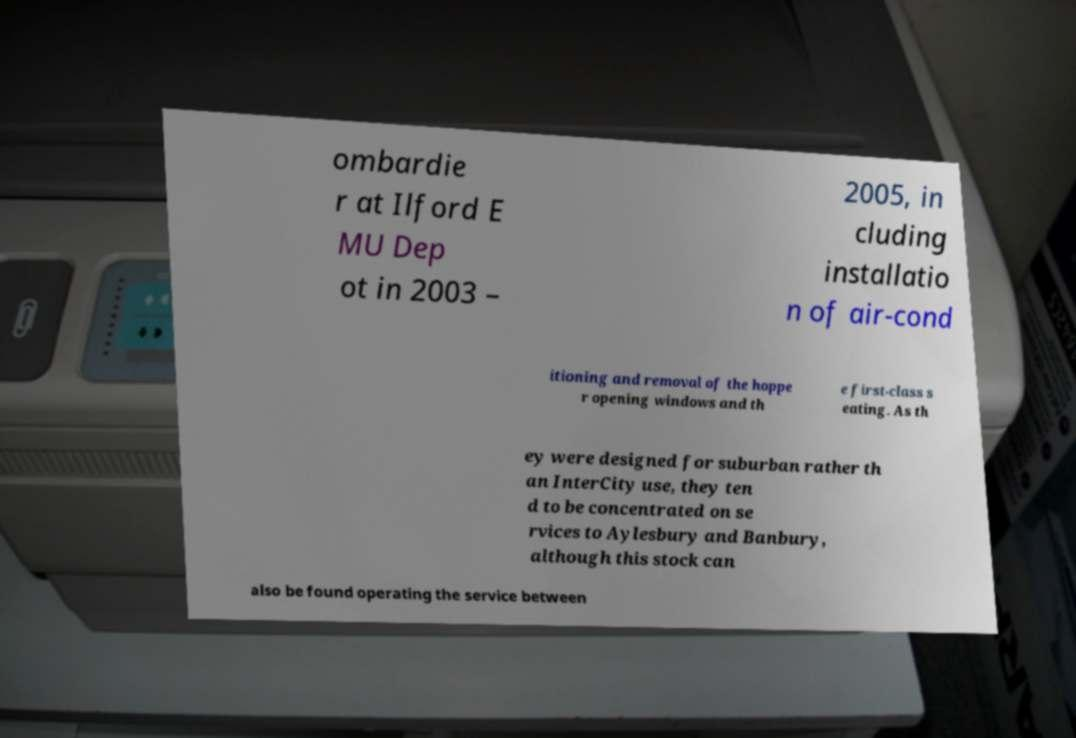Please read and relay the text visible in this image. What does it say? ombardie r at Ilford E MU Dep ot in 2003 – 2005, in cluding installatio n of air-cond itioning and removal of the hoppe r opening windows and th e first-class s eating. As th ey were designed for suburban rather th an InterCity use, they ten d to be concentrated on se rvices to Aylesbury and Banbury, although this stock can also be found operating the service between 